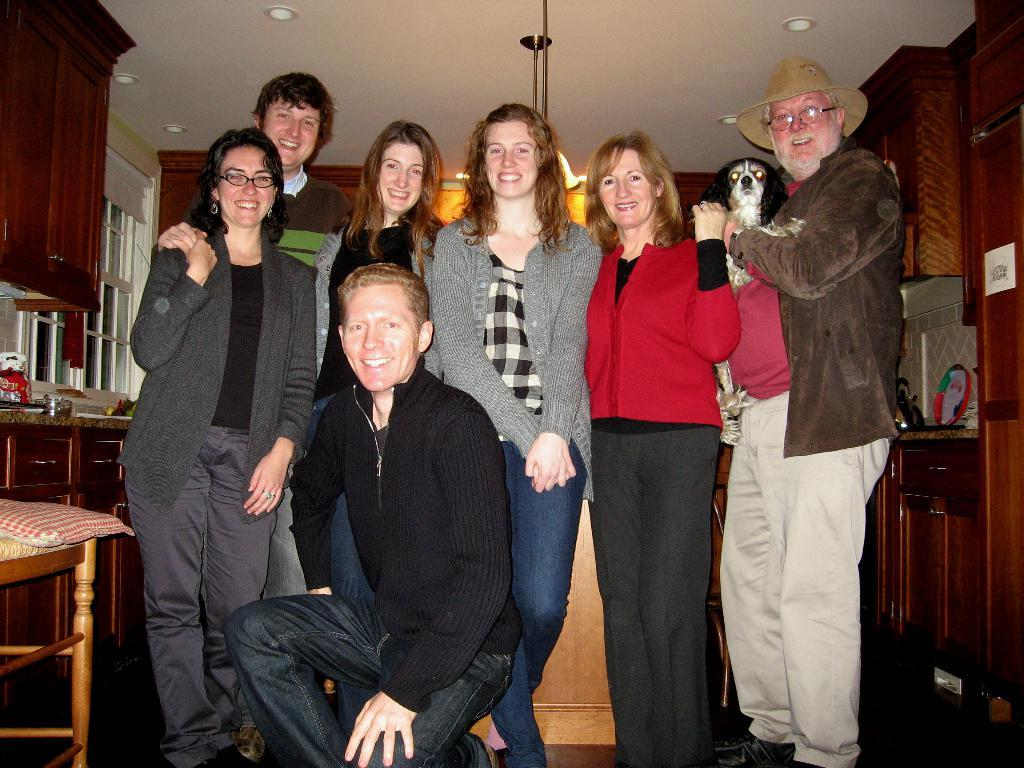Who or what is present in the image? There are people in the image. What are the people wearing? The people are wearing jackets. What type of furniture can be seen in the image? There is a chair in the image. What type of storage units are visible in the image? There are cupboards in the image. Can you describe any other objects in the image? There are other unspecified objects in the image. What type of pin can be seen holding the stone to the bird in the image? There is no pin, stone, or bird present in the image. 